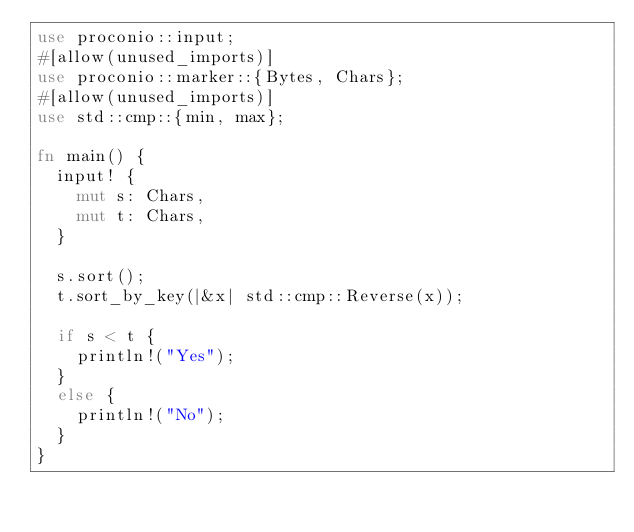Convert code to text. <code><loc_0><loc_0><loc_500><loc_500><_Rust_>use proconio::input;
#[allow(unused_imports)]
use proconio::marker::{Bytes, Chars};
#[allow(unused_imports)]
use std::cmp::{min, max};

fn main() {
	input! {
		mut s: Chars,
		mut t: Chars,
	}

	s.sort();
	t.sort_by_key(|&x| std::cmp::Reverse(x));

	if s < t {
		println!("Yes");
	}
	else {
		println!("No");
	}
}

</code> 